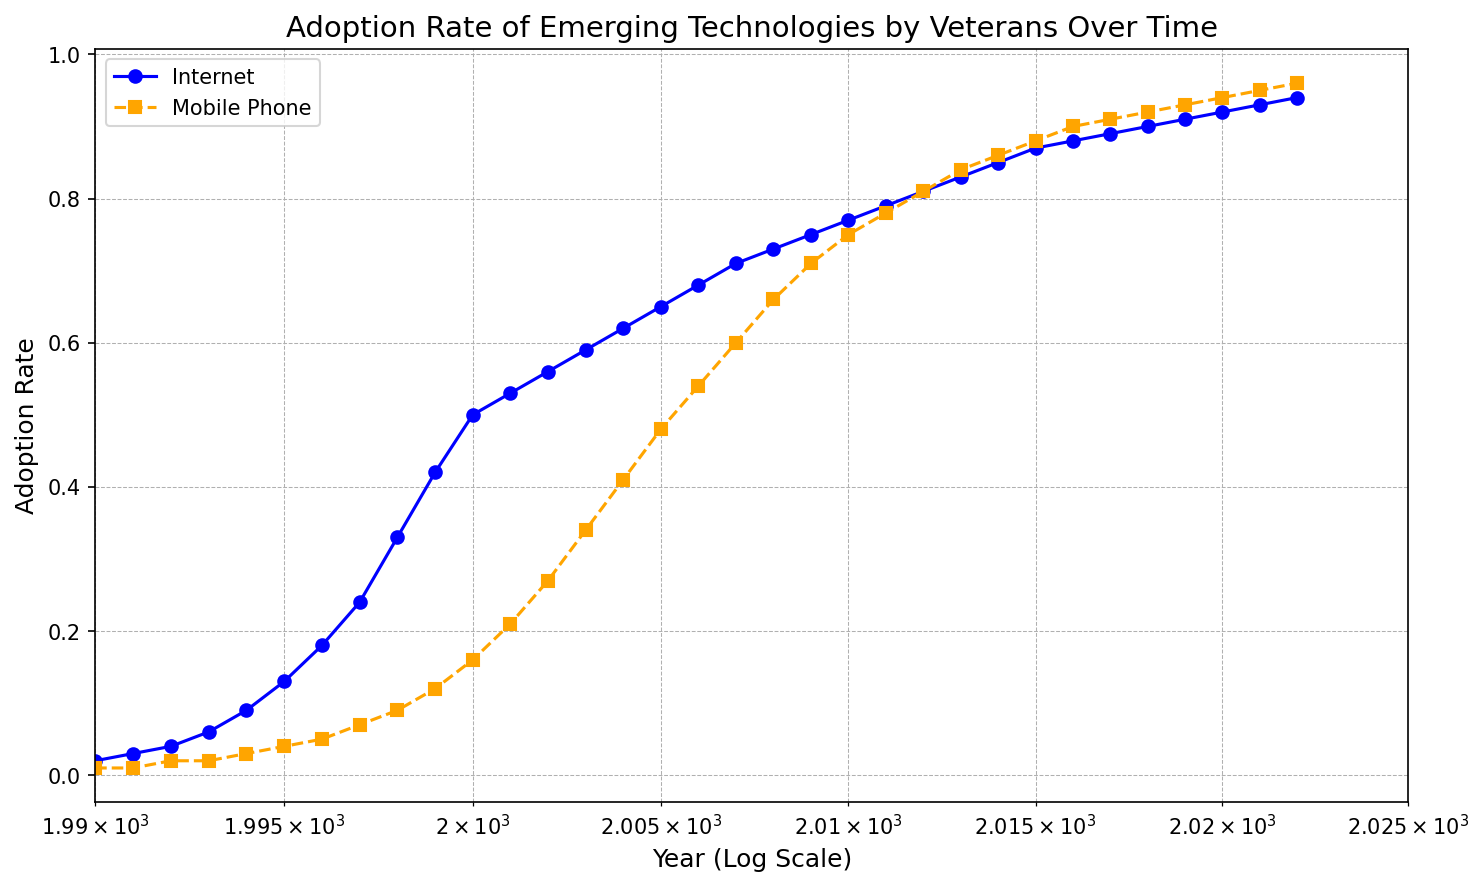What is the overall trend in the adoption rate of the Internet from 1990 to 2022? The plot shows the Internet adoption rate starting at 0.02 in 1990 and gradually increasing each year. By 2022, the adoption rate reaches 0.94. This indicates a steady and consistent increase over the years.
Answer: Steady increase What is the difference in adoption rates between Internet and Mobile Phone technologies in the year 2000? In 2000, the Internet adoption rate is 0.50 and the Mobile Phone adoption rate is 0.16. The difference is calculated by subtracting the Mobile Phone adoption rate from the Internet adoption rate: 0.50 - 0.16 = 0.34.
Answer: 0.34 Which technology had a faster initial adoption rate, Internet or Mobile Phone? By comparing the slopes of the lines in the early years (1990-1995), Mobile Phone technology appears to have a less steep slope, indicating a slower initial adoption rate compared to the Internet.
Answer: Internet At what point do both technologies (Internet and Mobile Phone) have similar adoption rates? Observing the lines for both technologies, the year 2009 stands out where the adoption rates of both technologies seem close. The Internet is at 0.75 and the Mobile Phone at approximately 0.71.
Answer: 2009 How does the log scale on the x-axis affect the interpretation of the adoption trends? The log scale compresses the earlier years (1990-2000) and stretches the later years (2000-2022). This makes it easier to compare rates in the initial adoption periods and see finer details in later years.
Answer: Easier comparison in early years What is the average adoption rate of the Internet from 1990 to 2000? Sum the adoption rates from 1990 to 2000: (0.02 + 0.03 + 0.04 + 0.06 + 0.09 + 0.13 + 0.18 + 0.24 + 0.33 + 0.42 + 0.50) = 2.04. Divide this sum by the number of years: 2.04 / 11 ≈ 0.185.
Answer: 0.185 Which year shows the largest increase in mobile phone adoption rate? By examining the dataset on the plot, the largest increase in Mobile Phone adoption rate is observed between the years 2002 to 2003, where it jumps from 0.27 to 0.34.
Answer: 2002-2003 How do the styles (line styles, markers, colors) help differentiate between the Internet and Mobile Phone trends? The Internet is represented with a solid blue line and circle markers, while the Mobile Phone is shown with a dashed orange line and square markers. This distinct differentiation in styles helps visually separate and easily identify the two trends.
Answer: Distinct styles for both What are the adoption rates of both technologies in 2015? In 2015, the Internet adoption rate is 0.87 and the Mobile Phone adoption rate is 0.88.
Answer: 0.87 and 0.88 Which technology shows a plateau in its adoption rate, and during what time period does this occur? The Internet adoption rate shows a plateau starting around 2001, where the increase in adoption rate slows down significantly. This suggests that adoption was nearing saturation during this period.
Answer: Internet, around 2001 